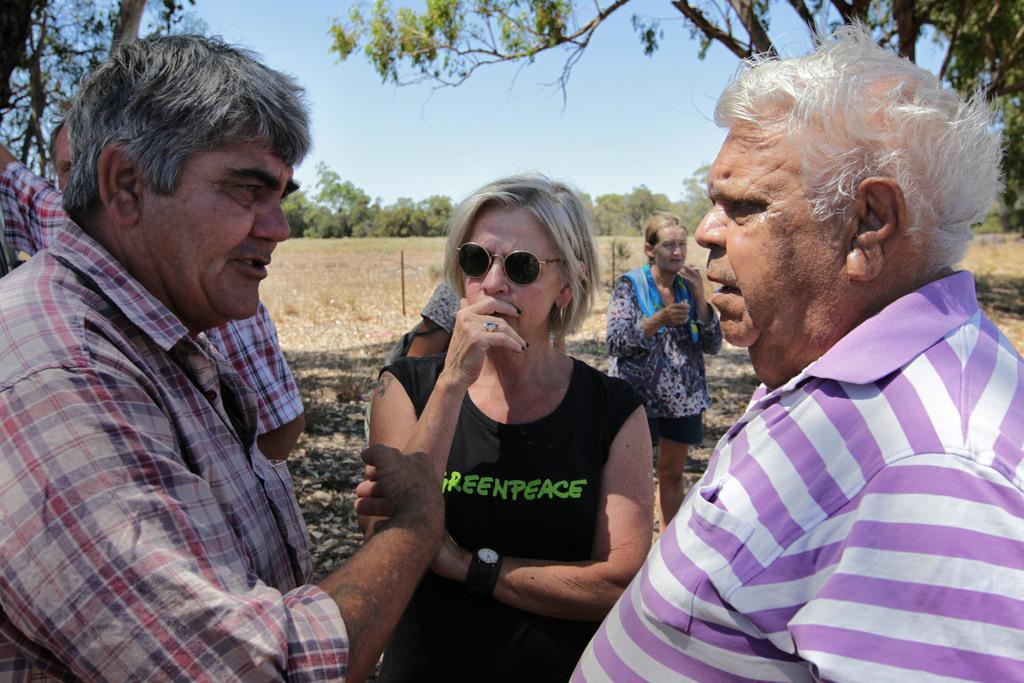Describe this image in one or two sentences. In this image we can see a group of people standing on the ground. On the backside we can see some poles, grass, a group of trees and the sky which looks cloudy. 